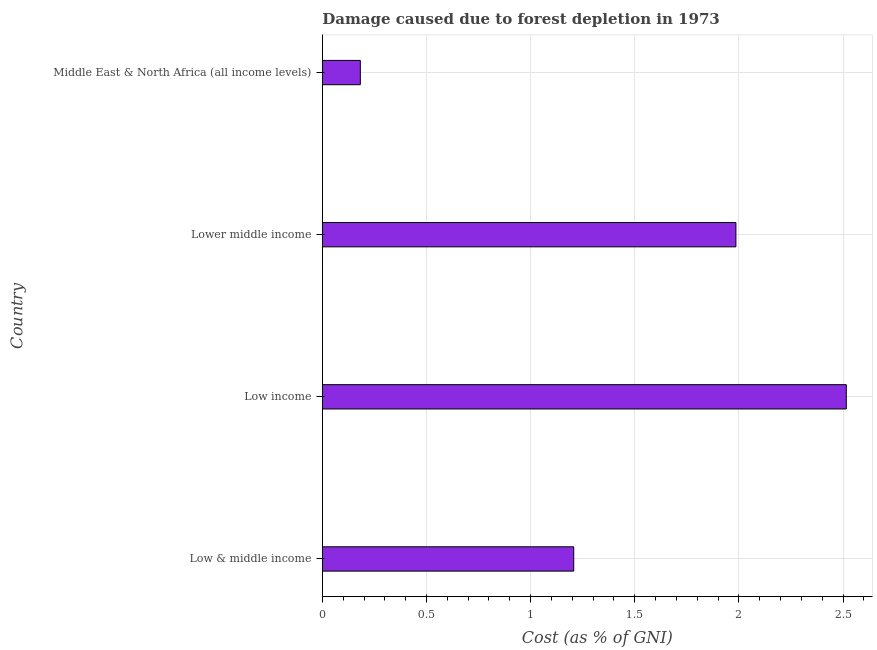Does the graph contain any zero values?
Provide a succinct answer. No. What is the title of the graph?
Ensure brevity in your answer.  Damage caused due to forest depletion in 1973. What is the label or title of the X-axis?
Your answer should be very brief. Cost (as % of GNI). What is the label or title of the Y-axis?
Your answer should be very brief. Country. What is the damage caused due to forest depletion in Lower middle income?
Make the answer very short. 1.99. Across all countries, what is the maximum damage caused due to forest depletion?
Your response must be concise. 2.52. Across all countries, what is the minimum damage caused due to forest depletion?
Your answer should be very brief. 0.18. In which country was the damage caused due to forest depletion maximum?
Provide a short and direct response. Low income. In which country was the damage caused due to forest depletion minimum?
Ensure brevity in your answer.  Middle East & North Africa (all income levels). What is the sum of the damage caused due to forest depletion?
Provide a succinct answer. 5.89. What is the difference between the damage caused due to forest depletion in Low & middle income and Lower middle income?
Your response must be concise. -0.78. What is the average damage caused due to forest depletion per country?
Your answer should be compact. 1.47. What is the median damage caused due to forest depletion?
Give a very brief answer. 1.6. In how many countries, is the damage caused due to forest depletion greater than 1.7 %?
Your answer should be compact. 2. What is the ratio of the damage caused due to forest depletion in Lower middle income to that in Middle East & North Africa (all income levels)?
Keep it short and to the point. 10.88. What is the difference between the highest and the second highest damage caused due to forest depletion?
Keep it short and to the point. 0.53. What is the difference between the highest and the lowest damage caused due to forest depletion?
Give a very brief answer. 2.33. How many bars are there?
Provide a short and direct response. 4. What is the difference between two consecutive major ticks on the X-axis?
Keep it short and to the point. 0.5. Are the values on the major ticks of X-axis written in scientific E-notation?
Ensure brevity in your answer.  No. What is the Cost (as % of GNI) in Low & middle income?
Your response must be concise. 1.21. What is the Cost (as % of GNI) in Low income?
Your response must be concise. 2.52. What is the Cost (as % of GNI) of Lower middle income?
Keep it short and to the point. 1.99. What is the Cost (as % of GNI) of Middle East & North Africa (all income levels)?
Provide a succinct answer. 0.18. What is the difference between the Cost (as % of GNI) in Low & middle income and Low income?
Give a very brief answer. -1.31. What is the difference between the Cost (as % of GNI) in Low & middle income and Lower middle income?
Give a very brief answer. -0.78. What is the difference between the Cost (as % of GNI) in Low & middle income and Middle East & North Africa (all income levels)?
Offer a terse response. 1.02. What is the difference between the Cost (as % of GNI) in Low income and Lower middle income?
Your answer should be very brief. 0.53. What is the difference between the Cost (as % of GNI) in Low income and Middle East & North Africa (all income levels)?
Your answer should be compact. 2.33. What is the difference between the Cost (as % of GNI) in Lower middle income and Middle East & North Africa (all income levels)?
Your response must be concise. 1.8. What is the ratio of the Cost (as % of GNI) in Low & middle income to that in Low income?
Offer a terse response. 0.48. What is the ratio of the Cost (as % of GNI) in Low & middle income to that in Lower middle income?
Offer a very short reply. 0.61. What is the ratio of the Cost (as % of GNI) in Low & middle income to that in Middle East & North Africa (all income levels)?
Give a very brief answer. 6.62. What is the ratio of the Cost (as % of GNI) in Low income to that in Lower middle income?
Keep it short and to the point. 1.27. What is the ratio of the Cost (as % of GNI) in Low income to that in Middle East & North Africa (all income levels)?
Offer a very short reply. 13.79. What is the ratio of the Cost (as % of GNI) in Lower middle income to that in Middle East & North Africa (all income levels)?
Ensure brevity in your answer.  10.88. 